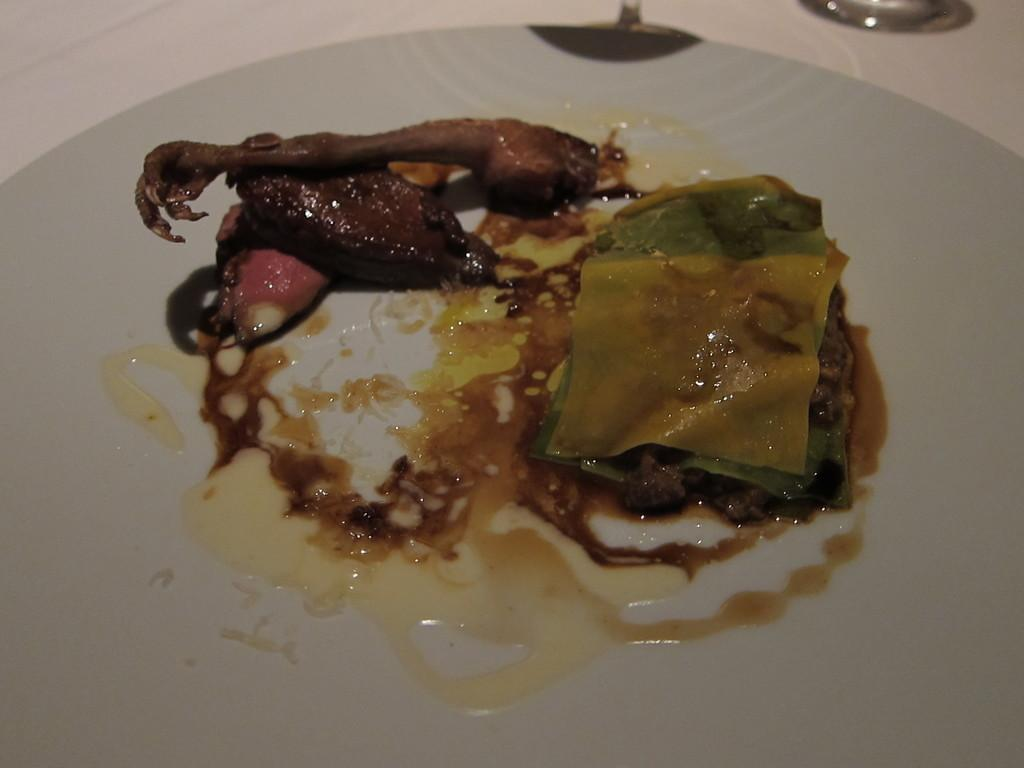What is present on the plate in the image? There is a food item on the plate. What is the color of the plate? The plate is white in color. What is the texture of the detail on the plate? There is no detail mentioned on the plate, and therefore no texture can be described. 